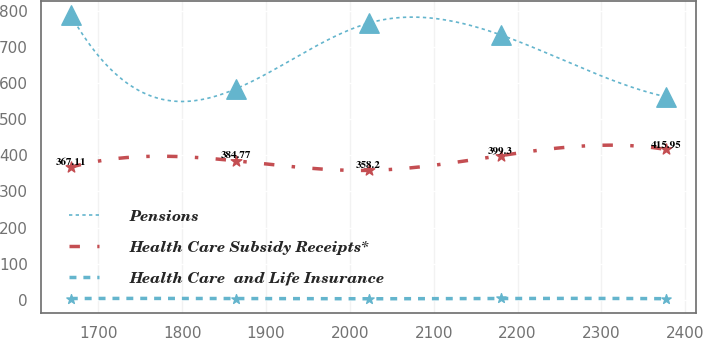<chart> <loc_0><loc_0><loc_500><loc_500><line_chart><ecel><fcel>Pensions<fcel>Health Care Subsidy Receipts*<fcel>Health Care  and Life Insurance<nl><fcel>1667.32<fcel>787.26<fcel>367.11<fcel>3.93<nl><fcel>1863.81<fcel>583.36<fcel>384.77<fcel>3.81<nl><fcel>2022.48<fcel>765.4<fcel>358.2<fcel>3.24<nl><fcel>2180.13<fcel>732.68<fcel>399.3<fcel>4.01<nl><fcel>2377.34<fcel>561.5<fcel>415.95<fcel>3.42<nl></chart> 